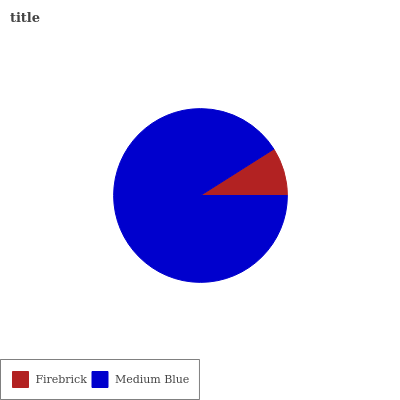Is Firebrick the minimum?
Answer yes or no. Yes. Is Medium Blue the maximum?
Answer yes or no. Yes. Is Medium Blue the minimum?
Answer yes or no. No. Is Medium Blue greater than Firebrick?
Answer yes or no. Yes. Is Firebrick less than Medium Blue?
Answer yes or no. Yes. Is Firebrick greater than Medium Blue?
Answer yes or no. No. Is Medium Blue less than Firebrick?
Answer yes or no. No. Is Medium Blue the high median?
Answer yes or no. Yes. Is Firebrick the low median?
Answer yes or no. Yes. Is Firebrick the high median?
Answer yes or no. No. Is Medium Blue the low median?
Answer yes or no. No. 